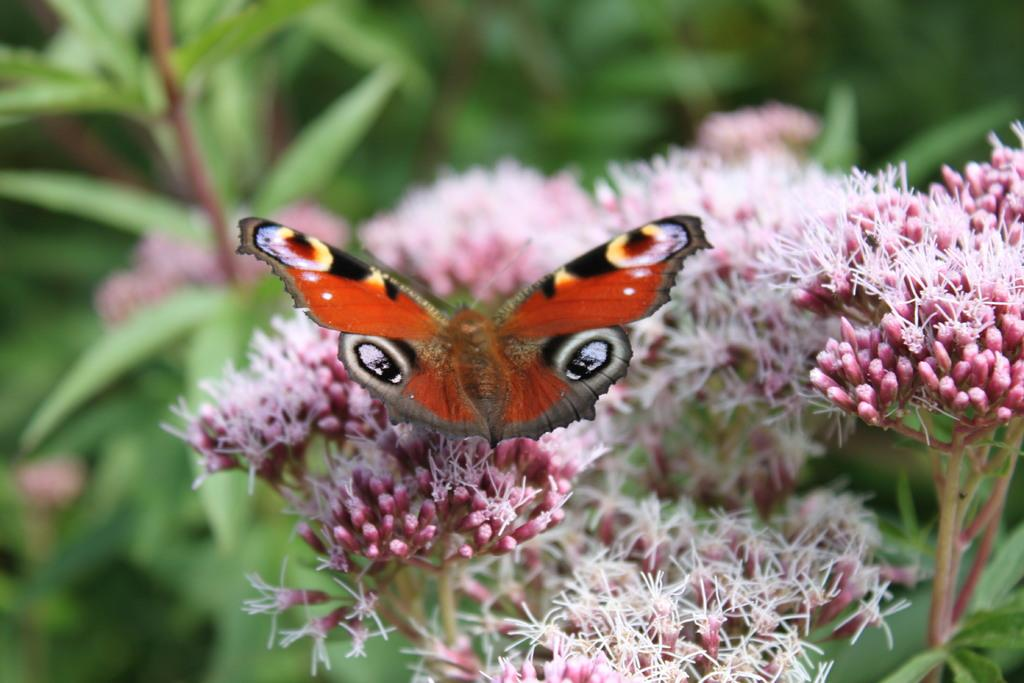What is the main subject of the image? There is a butterfly in the image. Where is the butterfly located? The butterfly is on flowers. What can be seen in the background of the image? There are plants in the background of the image. What type of whip can be seen in the image? There is no whip present in the image; it features a butterfly on flowers with plants in the background. 